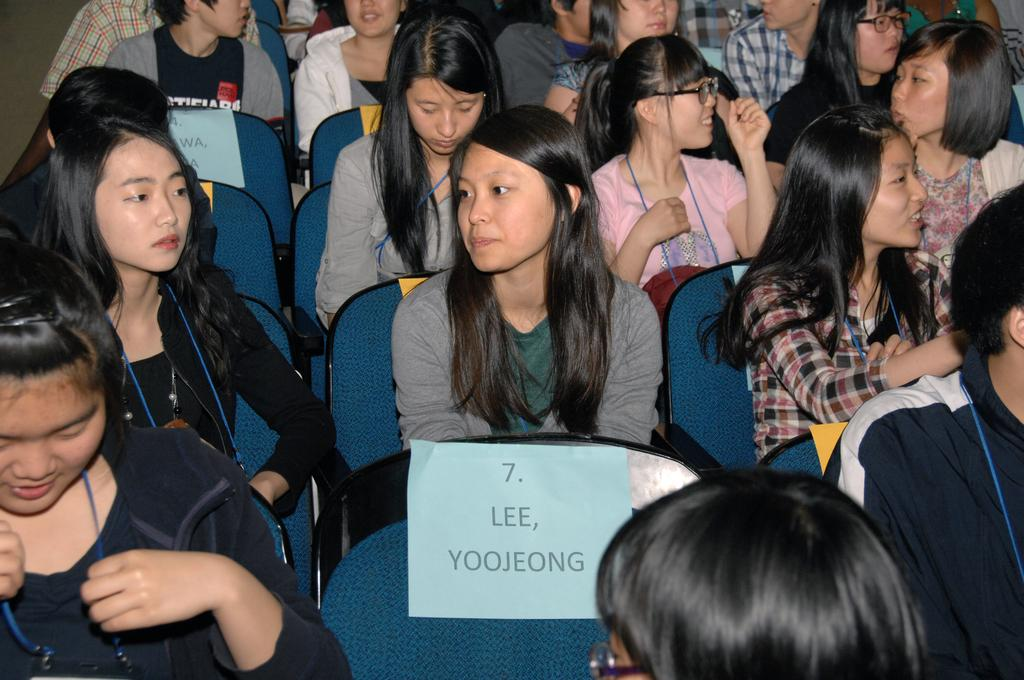What are the people in the image doing? The people in the image are sitting on chairs. Can you describe the paper at the bottom of the image? The paper has a blue color and text written on it. What type of sand can be seen in the image? There is no sand present in the image. How many people are folding their chairs in the image? There is no indication in the image that anyone is folding chairs. 